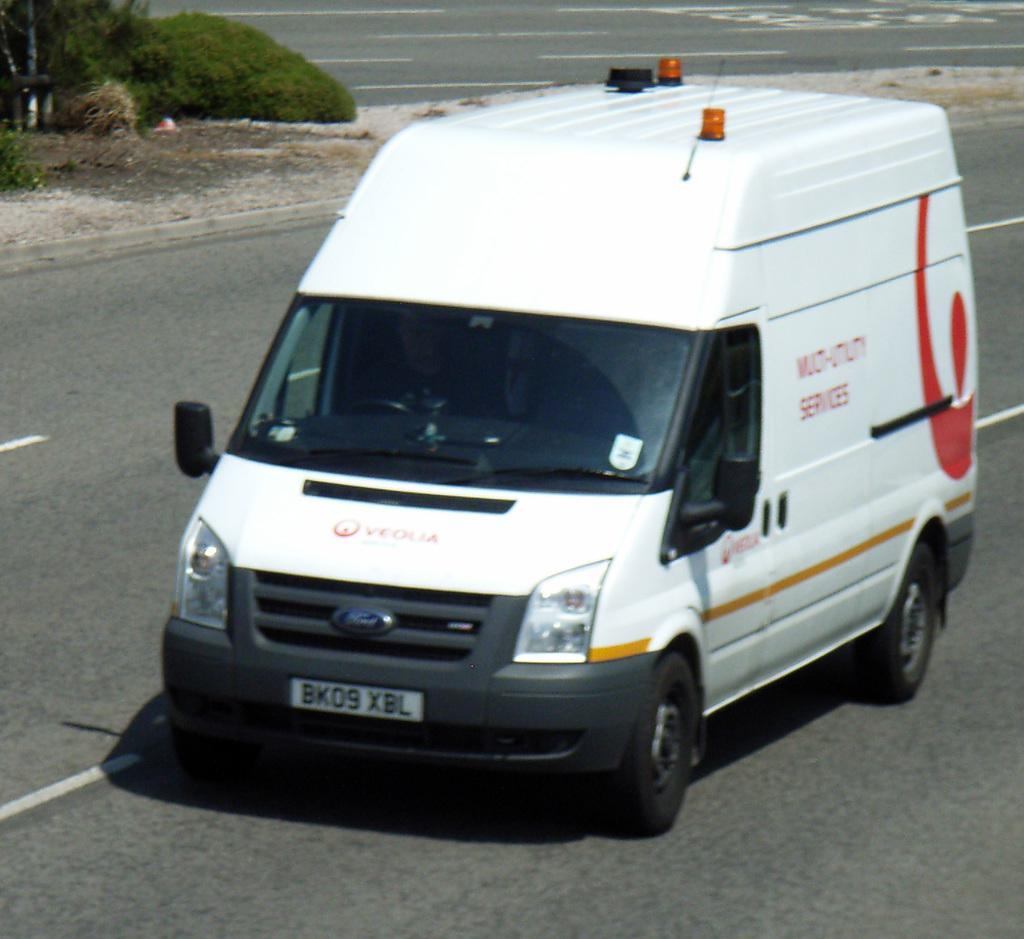<image>
Offer a succinct explanation of the picture presented. a white Ford van has a plate BK09 XBL 